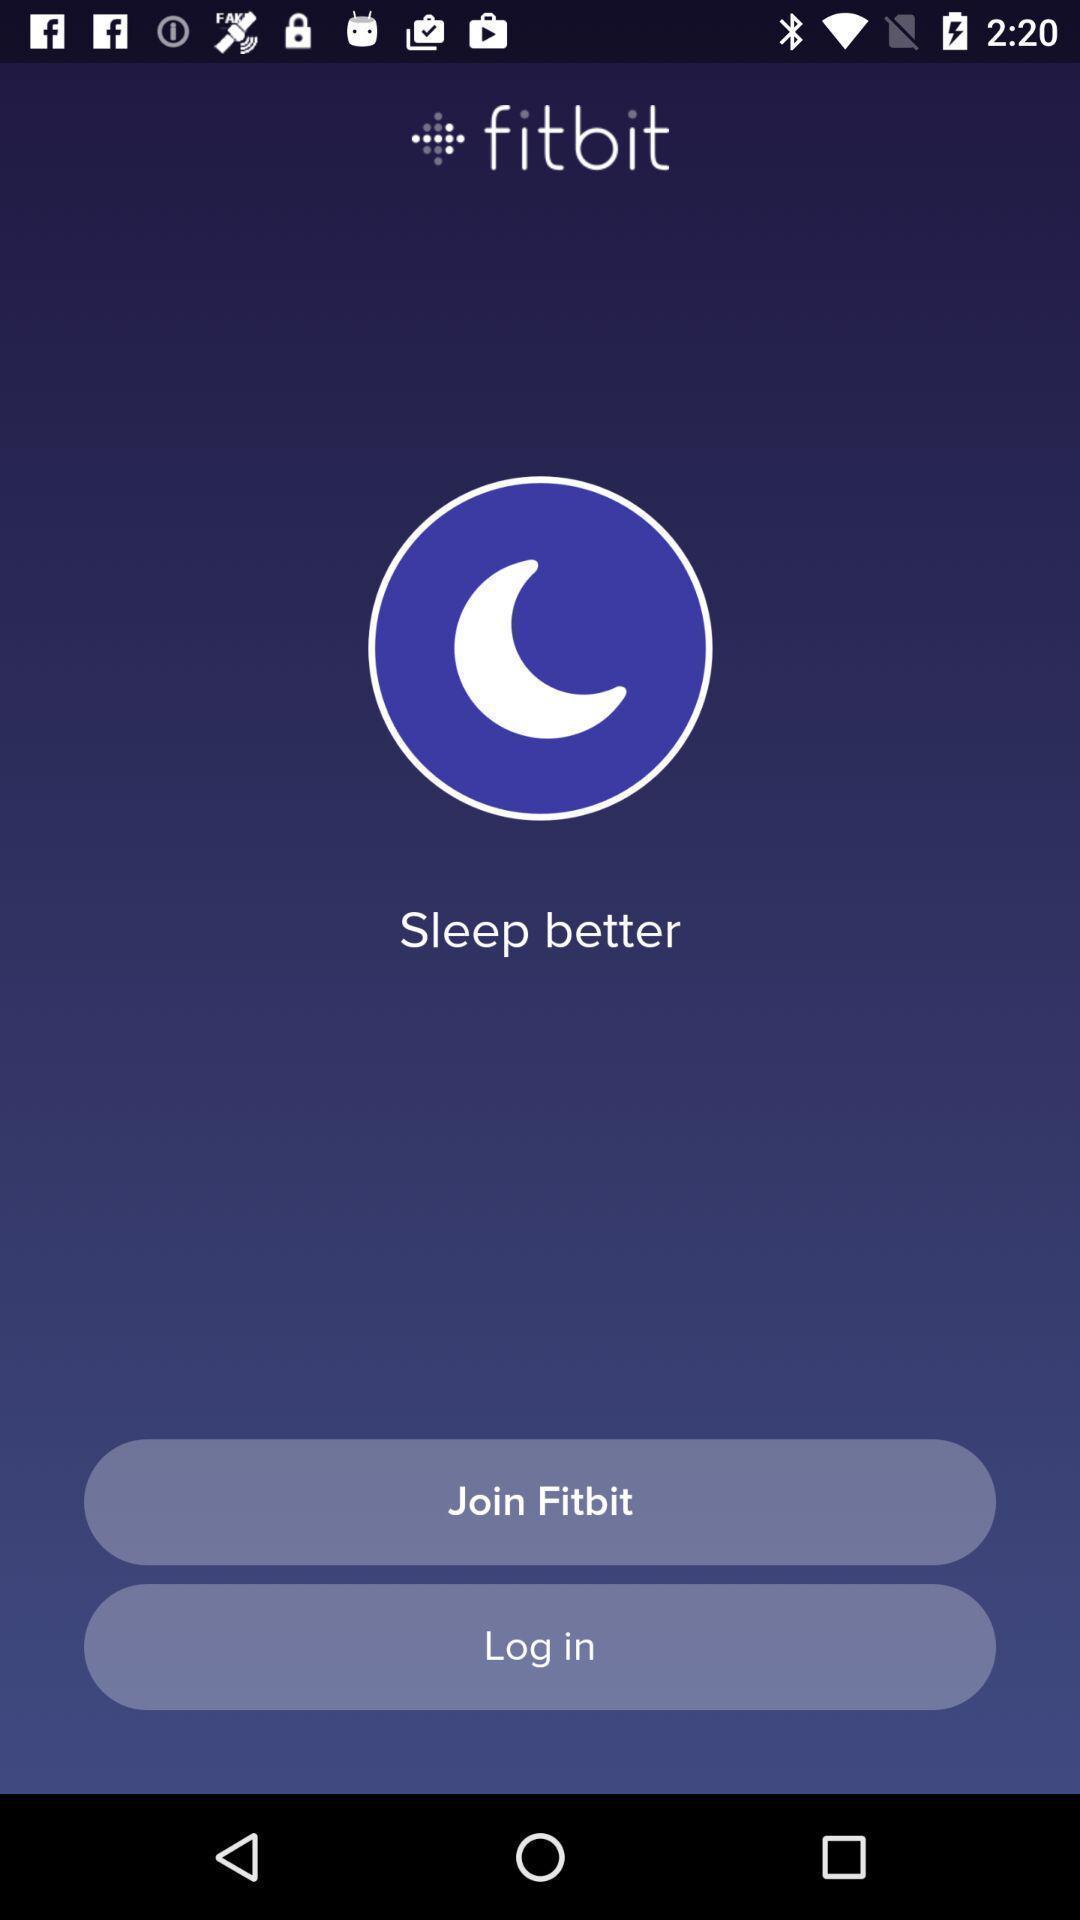Summarize the main components in this picture. Login page. 